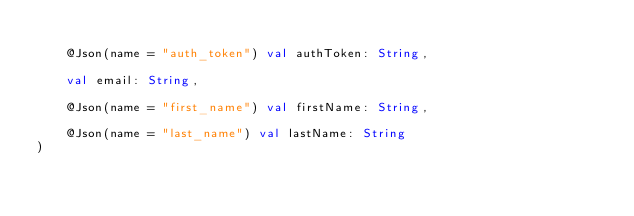Convert code to text. <code><loc_0><loc_0><loc_500><loc_500><_Kotlin_>
    @Json(name = "auth_token") val authToken: String,

    val email: String,

    @Json(name = "first_name") val firstName: String,

    @Json(name = "last_name") val lastName: String
)</code> 